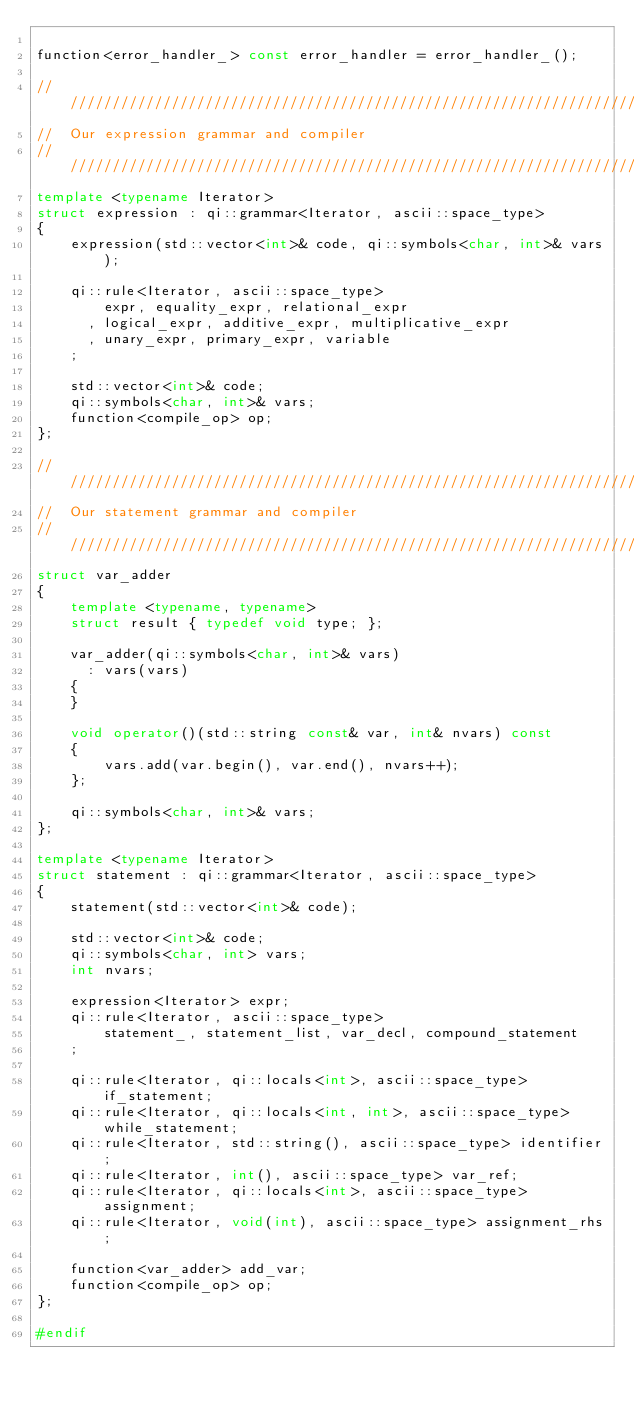<code> <loc_0><loc_0><loc_500><loc_500><_C++_>
function<error_handler_> const error_handler = error_handler_();

///////////////////////////////////////////////////////////////////////////////
//  Our expression grammar and compiler
///////////////////////////////////////////////////////////////////////////////
template <typename Iterator>
struct expression : qi::grammar<Iterator, ascii::space_type>
{
    expression(std::vector<int>& code, qi::symbols<char, int>& vars);

    qi::rule<Iterator, ascii::space_type>
        expr, equality_expr, relational_expr
      , logical_expr, additive_expr, multiplicative_expr
      , unary_expr, primary_expr, variable
    ;

    std::vector<int>& code;
    qi::symbols<char, int>& vars;
    function<compile_op> op;
};

///////////////////////////////////////////////////////////////////////////////
//  Our statement grammar and compiler
///////////////////////////////////////////////////////////////////////////////
struct var_adder
{
    template <typename, typename>
    struct result { typedef void type; };

    var_adder(qi::symbols<char, int>& vars)
      : vars(vars)
    {
    }

    void operator()(std::string const& var, int& nvars) const
    {
        vars.add(var.begin(), var.end(), nvars++);
    };

    qi::symbols<char, int>& vars;
};

template <typename Iterator>
struct statement : qi::grammar<Iterator, ascii::space_type>
{
    statement(std::vector<int>& code);

    std::vector<int>& code;
    qi::symbols<char, int> vars;
    int nvars;

    expression<Iterator> expr;
    qi::rule<Iterator, ascii::space_type>
        statement_, statement_list, var_decl, compound_statement
    ;

    qi::rule<Iterator, qi::locals<int>, ascii::space_type> if_statement;
    qi::rule<Iterator, qi::locals<int, int>, ascii::space_type> while_statement;
    qi::rule<Iterator, std::string(), ascii::space_type> identifier;
    qi::rule<Iterator, int(), ascii::space_type> var_ref;
    qi::rule<Iterator, qi::locals<int>, ascii::space_type> assignment;
    qi::rule<Iterator, void(int), ascii::space_type> assignment_rhs;

    function<var_adder> add_var;
    function<compile_op> op;
};

#endif
</code> 